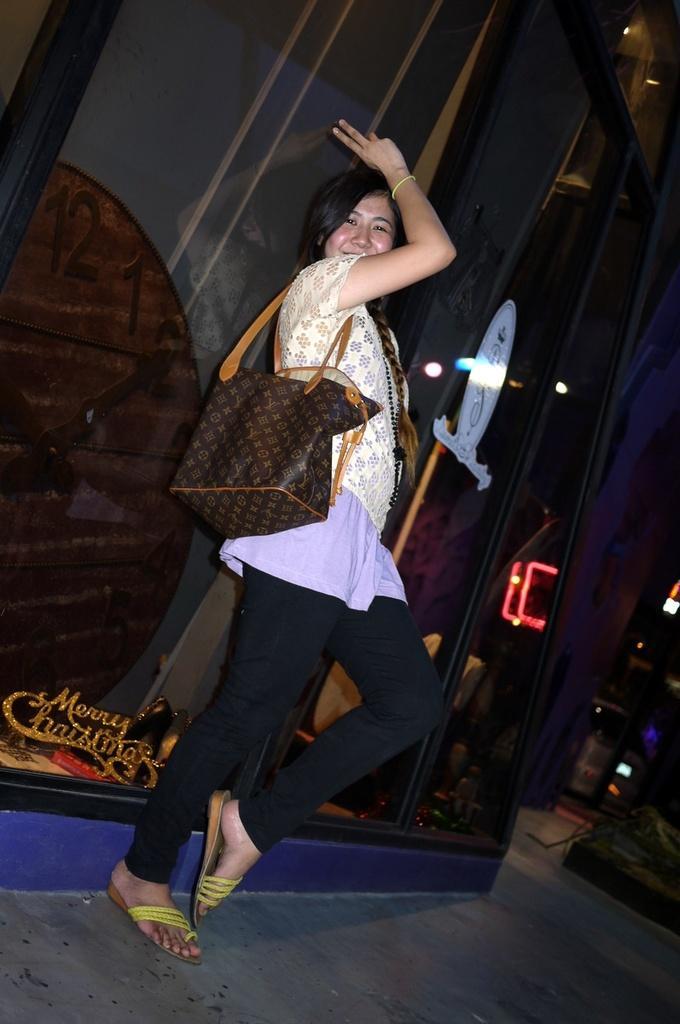Please provide a concise description of this image. In the middle of the image a woman is standing and smiling. Behind her there is a wall. 